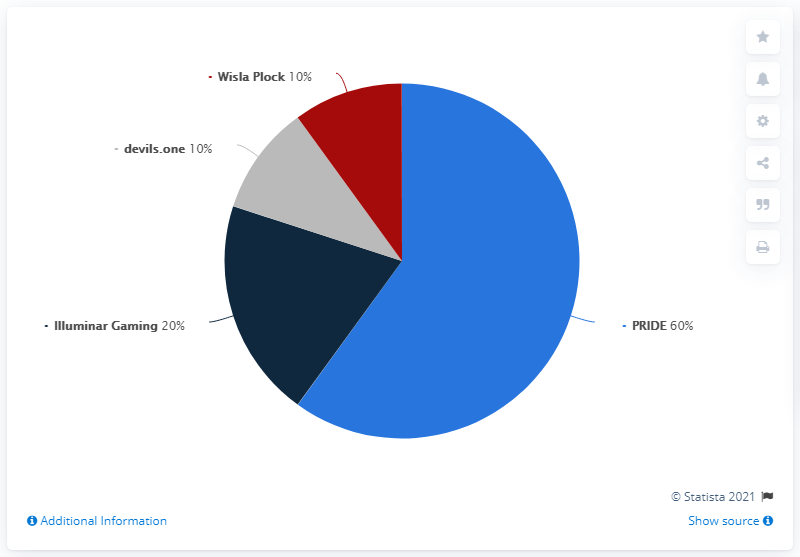Indicate a few pertinent items in this graphic. PRIDE's prize pool is larger than that of all other teams combined together. There are three acute angles in the pie chart. 